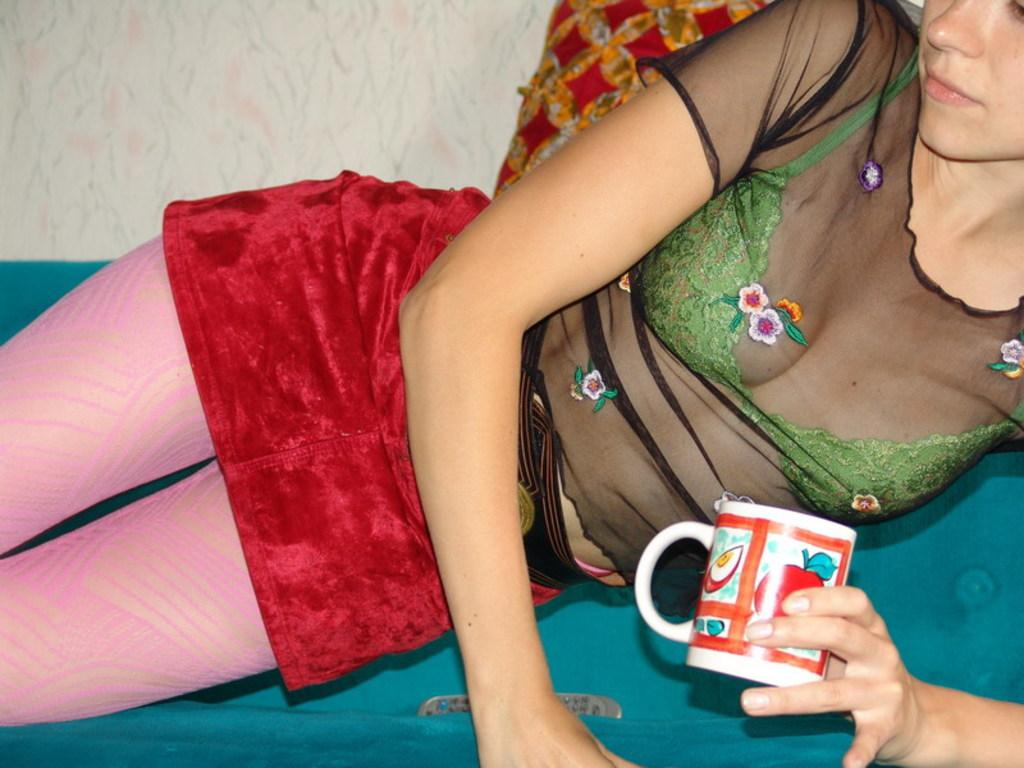Who is present in the image? There is a woman in the image. What is the woman doing in the image? The woman is laying on the bed. What object is the woman holding in her hand? The woman is holding a cup in her hand. What type of scissors can be seen on the farm in the image? There is no farm or scissors present in the image; it features a woman laying on a bed and holding a cup. 